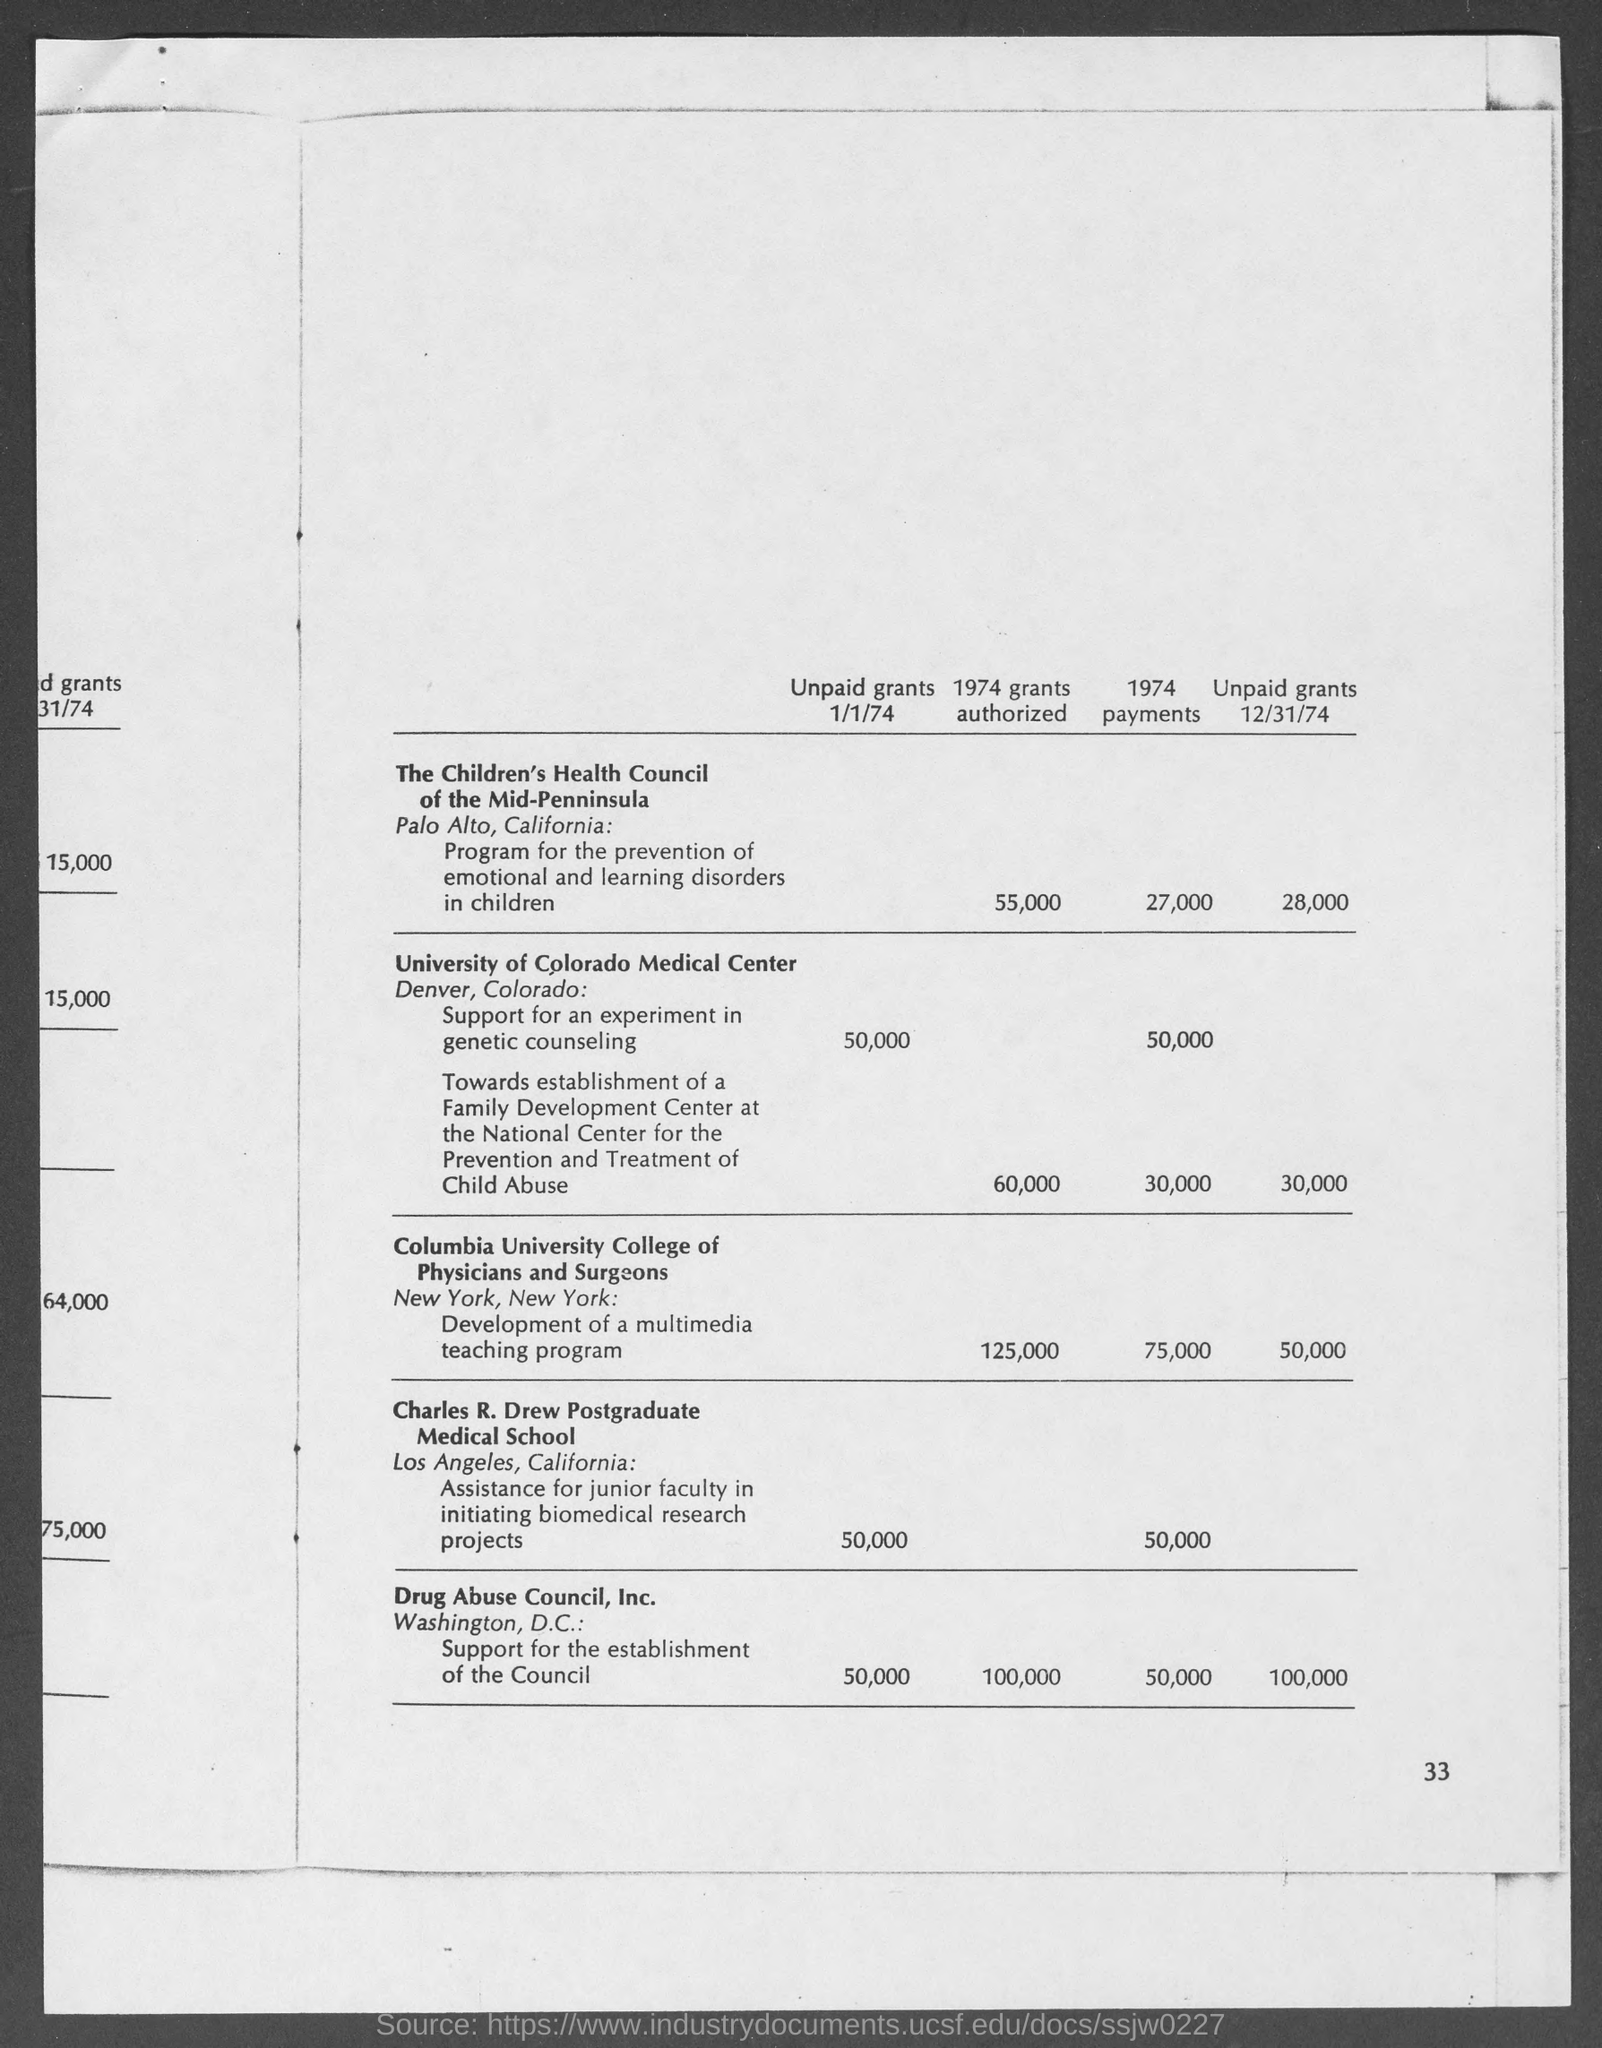Point out several critical features in this image. The Children's Health Council of the Mid-Penninsula was authorized to receive a grant of $55,000 in 1974. As of 12/31/74, the amount of unpaid grants for the Children's Health Council of the Mid-Penninsula was $28,000. On January 1st, 1974, the amount of unpaid grants at the University of Colorado Medical Center was $50,000. In 1974, the Children's Health Council of the Mid-Penninsula received payments totaling 27,000. 